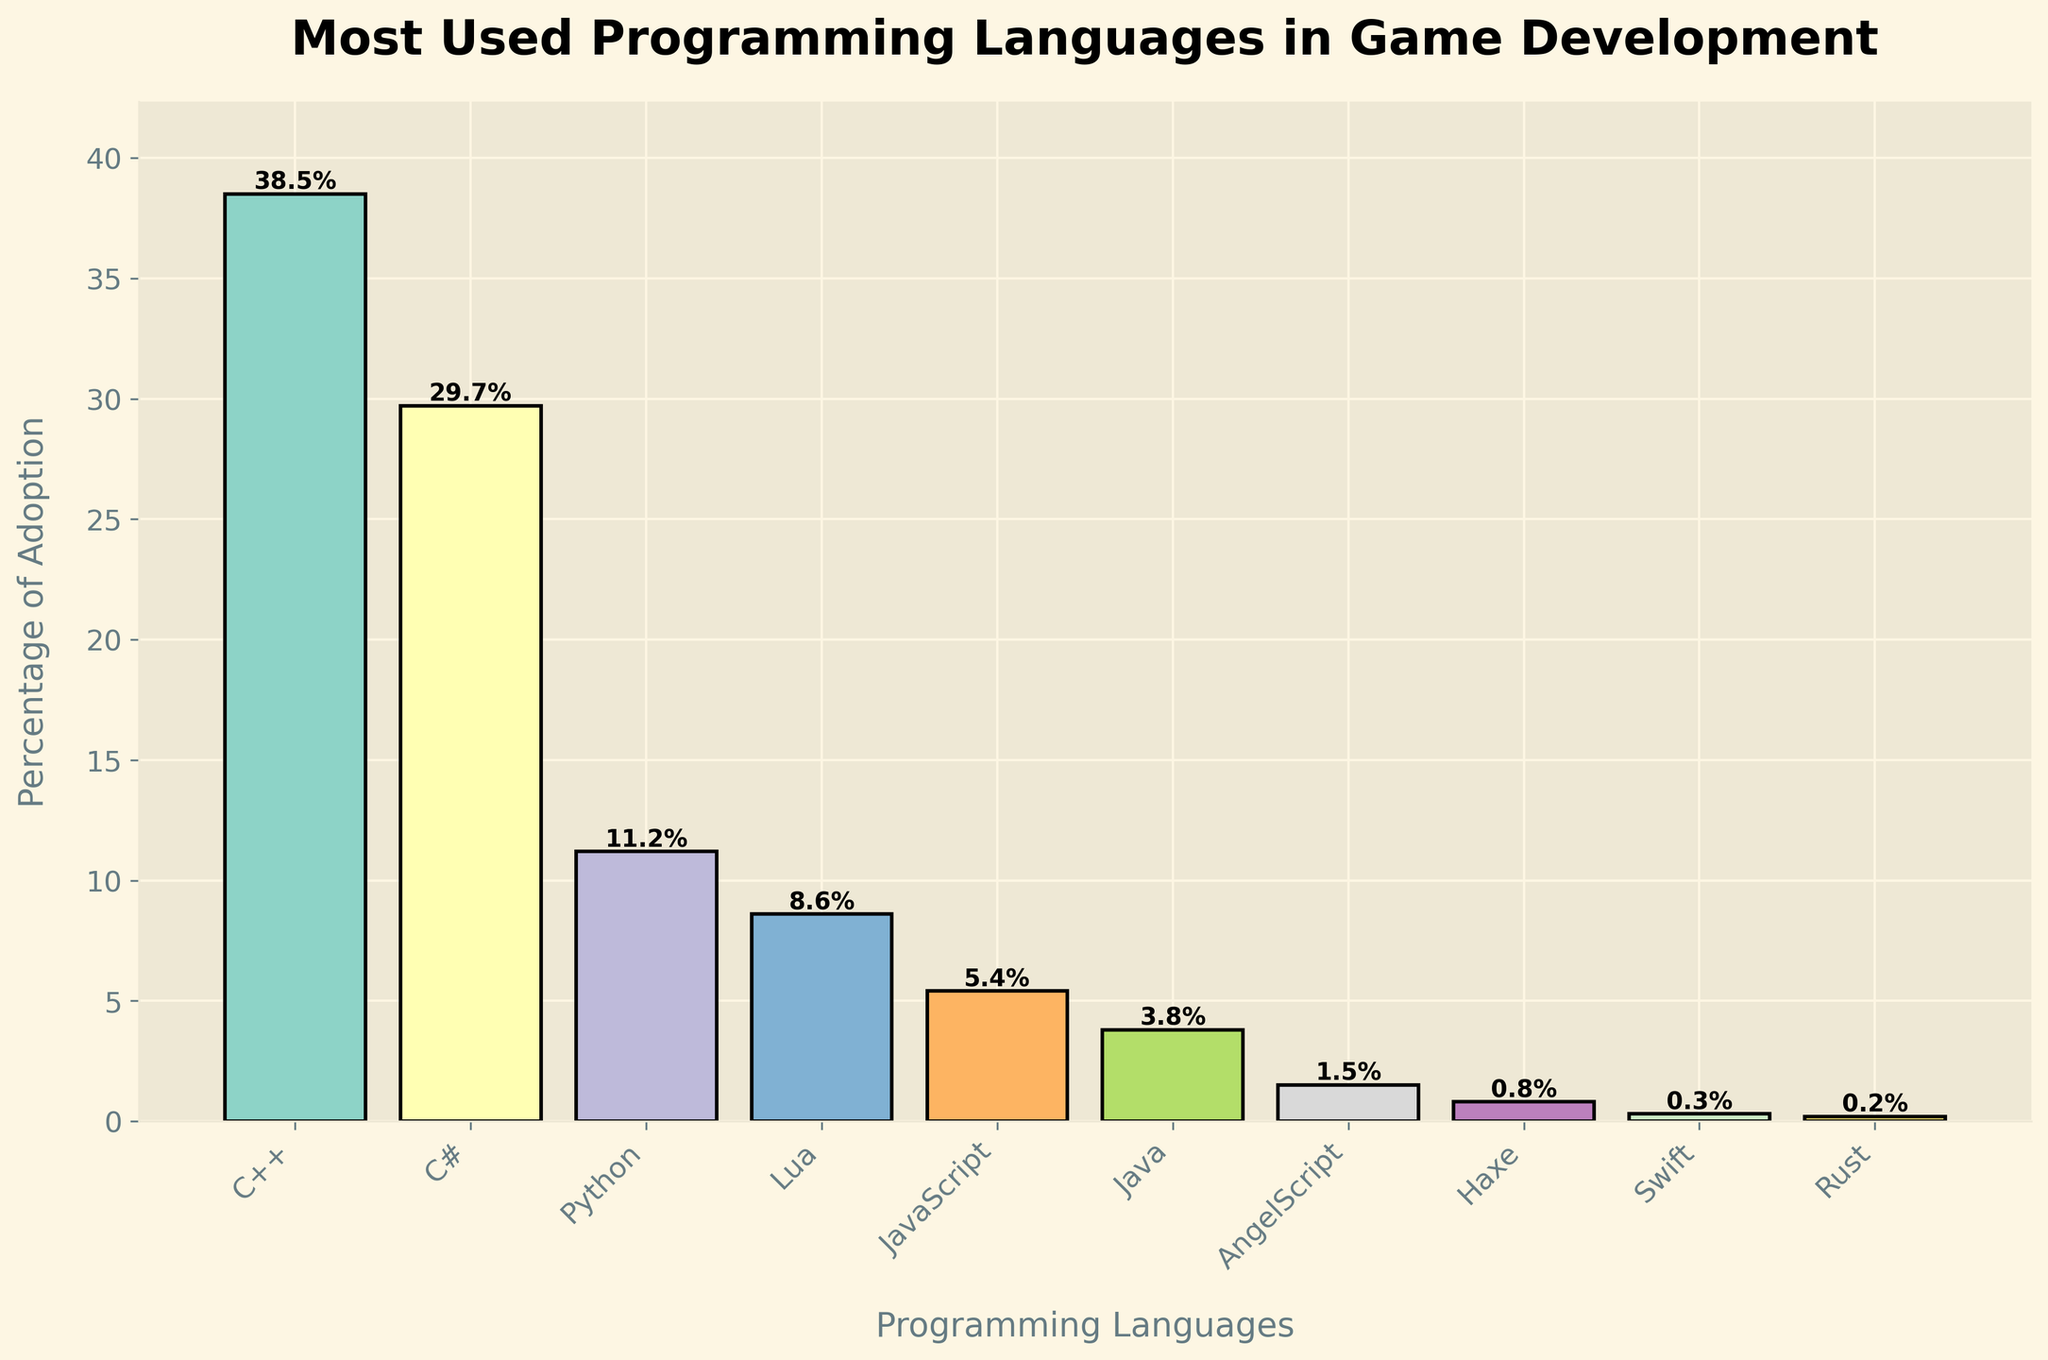What's the most used programming language in game development according to the chart? The chart title and corresponding values show the percentage of adoption for each language. The language with the highest percentage is the most used.
Answer: C++ Which programming language has a higher adoption rate, Python or JavaScript? By comparing the bars for Python and JavaScript, we see that Python's bar is taller than JavaScript's. The corresponding percentages show Python at 11.2% and JavaScript at 5.4%.
Answer: Python What is the total percentage of adoption for C++ and C# combined? C++ has an adoption of 38.5%, and C# has an adoption of 29.7%. Adding these two percentages gives you the combined total: 38.5% + 29.7% = 68.2%.
Answer: 68.2% What's the adoption rate difference between Lua and AngelScript? The adoption rates given for Lua and AngelScript are 8.6% and 1.5%, respectively. The difference is found by subtracting the smaller percentage from the larger one: 8.6% - 1.5% = 7.1%.
Answer: 7.1% Which language has the lowest adoption rate in the chart? Observing the heights of the bars and corresponding percentages, Rust has the lowest adoption rate at 0.2%.
Answer: Rust What's the average adoption rate of all the programming languages listed? To calculate the average percentage of adoption, sum all percentages and divide by the number of languages: (38.5 + 29.7 + 11.2 + 8.6 + 5.4 + 3.8 + 1.5 + 0.8 + 0.3 + 0.2) / 10 = 10%.
Answer: 10% How much more popular is Python than Java? Python has an adoption rate of 11.2%, while Java has 3.8%. The difference is calculated as 11.2% - 3.8% = 7.4%.
Answer: 7.4% Which programming language has the closest adoption rate to Lua? Comparing the values, Lua at 8.6% is closest in percentage to Python, which is 11.2%. The difference is 2.6, which is smaller compared to differences with other languages.
Answer: Python What is the sum percentage of languages with less than 1% adoption rate? Adding the percentages of Haxe, Swift, and Rust, which are below 1%: 0.8% + 0.3% + 0.2% = 1.3%.
Answer: 1.3% Between JavaScript and Lua, which one has a higher adoption rate and by how much? Comparing the percentages of JavaScript (5.4%) and Lua (8.6%) shows that Lua has a higher adoption rate. The difference is calculated as 8.6% - 5.4% = 3.2%.
Answer: Lua by 3.2% 